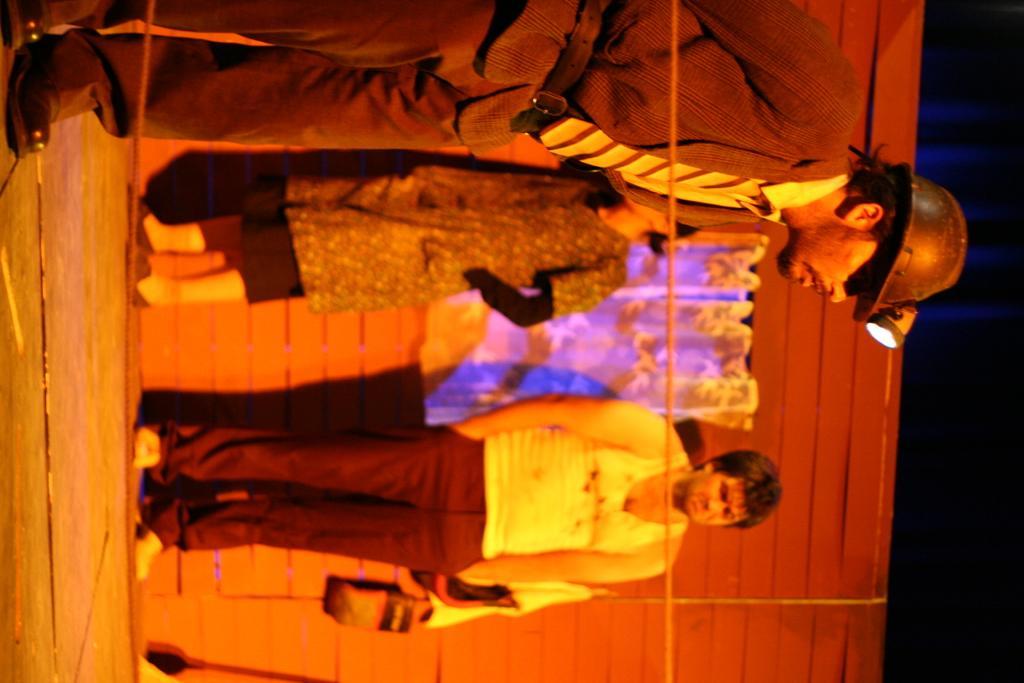Could you give a brief overview of what you see in this image? This image is in a right direction. Here I can see three people are standing and looking at the ground. In the background, I can see a wall and there is a curtain is hanging to it. 